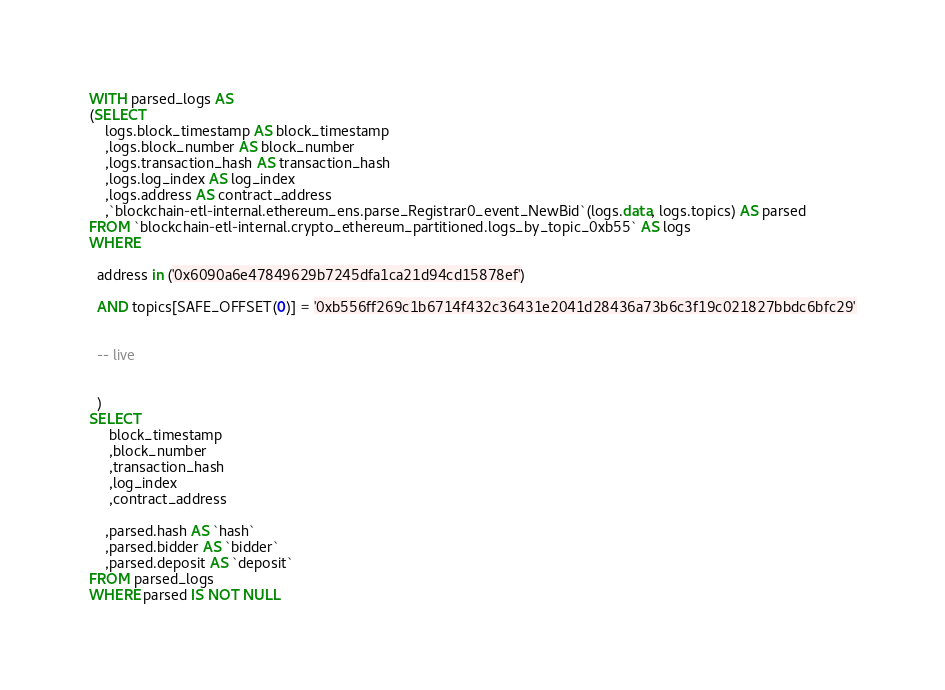Convert code to text. <code><loc_0><loc_0><loc_500><loc_500><_SQL_>WITH parsed_logs AS
(SELECT
    logs.block_timestamp AS block_timestamp
    ,logs.block_number AS block_number
    ,logs.transaction_hash AS transaction_hash
    ,logs.log_index AS log_index
    ,logs.address AS contract_address
    ,`blockchain-etl-internal.ethereum_ens.parse_Registrar0_event_NewBid`(logs.data, logs.topics) AS parsed
FROM `blockchain-etl-internal.crypto_ethereum_partitioned.logs_by_topic_0xb55` AS logs
WHERE

  address in ('0x6090a6e47849629b7245dfa1ca21d94cd15878ef')

  AND topics[SAFE_OFFSET(0)] = '0xb556ff269c1b6714f432c36431e2041d28436a73b6c3f19c021827bbdc6bfc29'


  -- live


  )
SELECT
     block_timestamp
     ,block_number
     ,transaction_hash
     ,log_index
     ,contract_address

    ,parsed.hash AS `hash`
    ,parsed.bidder AS `bidder`
    ,parsed.deposit AS `deposit`
FROM parsed_logs
WHERE parsed IS NOT NULL</code> 